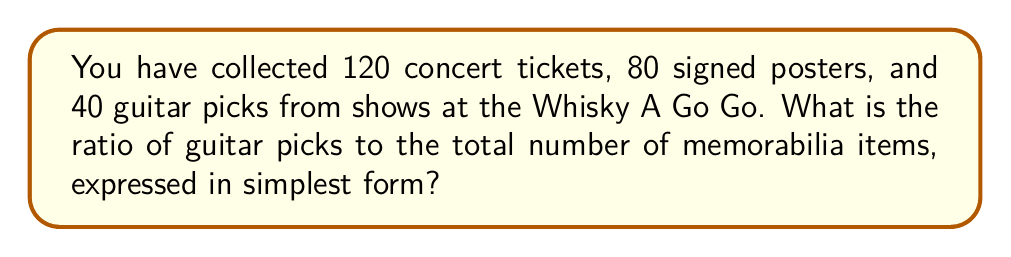Teach me how to tackle this problem. Let's approach this step-by-step:

1) First, we need to calculate the total number of memorabilia items:
   $$120 \text{ (tickets)} + 80 \text{ (posters)} + 40 \text{ (guitar picks)} = 240 \text{ (total items)}$$

2) Now, we want to find the ratio of guitar picks to the total number of items:
   $$\frac{\text{Number of guitar picks}}{\text{Total number of items}} = \frac{40}{240}$$

3) To simplify this ratio, we need to find the greatest common divisor (GCD) of 40 and 240:
   $$GCD(40, 240) = 40$$

4) Divide both the numerator and denominator by 40:
   $$\frac{40 \div 40}{240 \div 40} = \frac{1}{6}$$

Therefore, the ratio of guitar picks to the total number of memorabilia items, in its simplest form, is 1:6.
Answer: $1:6$ 